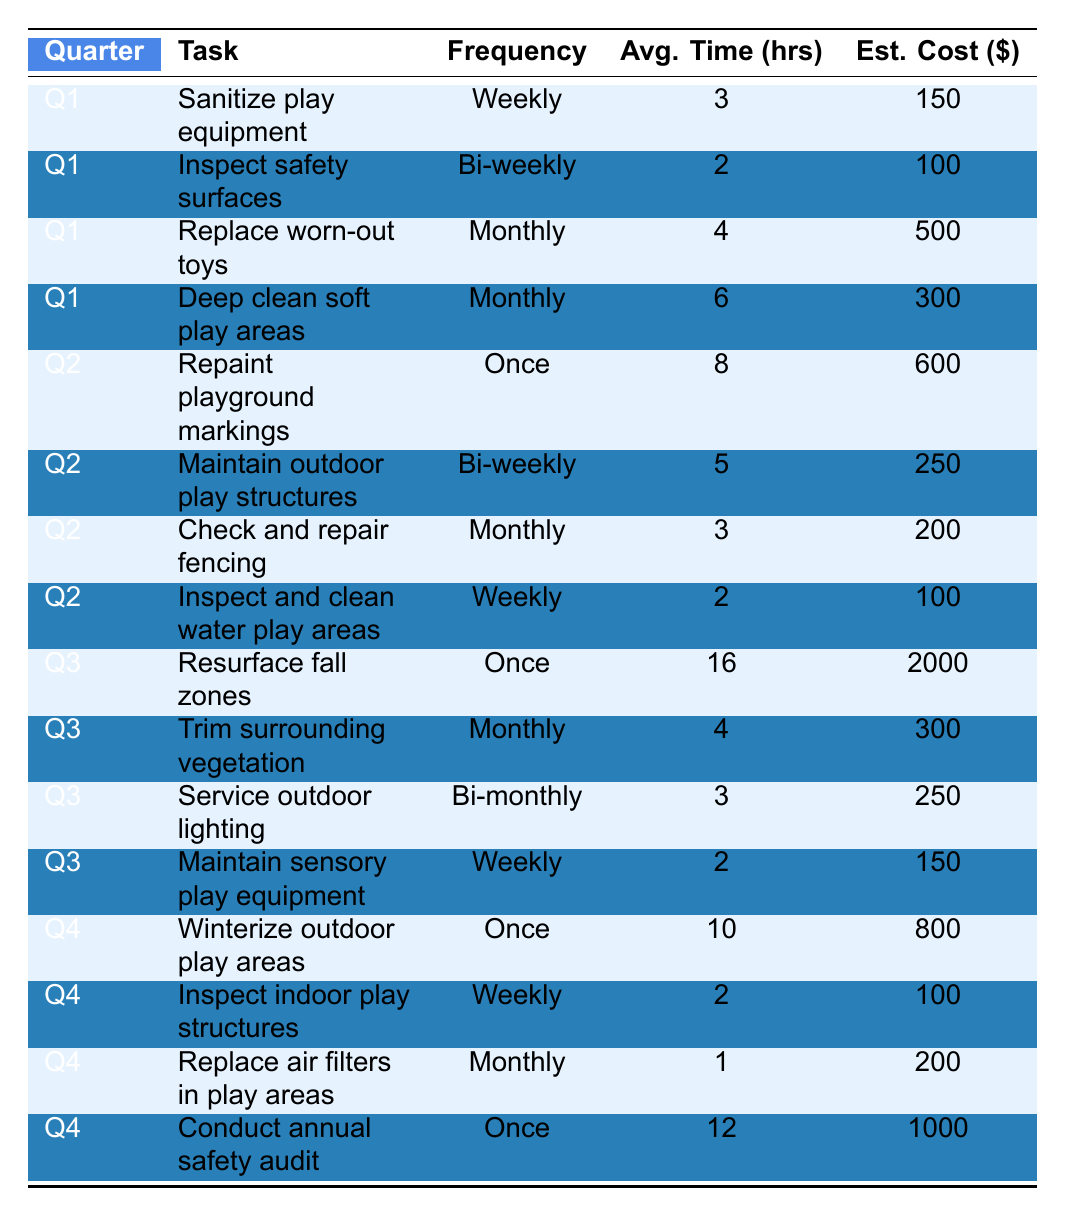What maintenance task has the highest estimated cost in Q3? In Q3, there are four tasks listed. The task "Resurface fall zones" has an estimated cost of $2000, which is higher than the other three tasks: "Trim surrounding vegetation" ($300), "Service outdoor lighting" ($250), and "Maintain sensory play equipment" ($150).
Answer: Resurface fall zones How often is the indoor play structure inspected? The table shows that the indoor play structures are inspected weekly in Q4.
Answer: Weekly What is the average time spent on tasks in Q2? The tasks in Q2 are: "Repaint playground markings" (8 hours), "Maintain outdoor play structures" (5 hours), "Check and repair fencing" (3 hours), and "Inspect and clean water play areas" (2 hours). Adding these gives 8 + 5 + 3 + 2 = 18 hours. Dividing by 4 (the number of tasks) gives an average of 18/4 = 4.5 hours.
Answer: 4.5 hours Is there a maintenance task that occurs monthly in Q4? The table lists three tasks for Q4, and one of them is "Replace air filters in play areas," which occurs monthly.
Answer: Yes What is the total estimated cost for all quarterly tasks? To find the total estimated cost, we sum each quarter's tasks: Q1 ($150 + $100 + $500 + $300), Q2 ($600 + $250 + $200 + $100), Q3 ($2000 + $300 + $250 + $150), and Q4 ($800 + $100 + $200 + $1000). Calculating these gives: Q1 = $1050, Q2 = $1150, Q3 = $2700, Q4 = $2100. Adding them together: $1050 + $1150 + $2700 + $2100 = $7100.
Answer: $7100 Which quarter has the highest total average time spent on maintenance tasks? First, we calculate total average time for each quarter: Q1 (3 + 2 + 4 + 6 = 15 hours), Q2 (8 + 5 + 3 + 2 = 18 hours), Q3 (16 + 4 + 3 + 2 = 25 hours), and Q4 (10 + 2 + 1 + 12 = 25 hours). Both Q3 and Q4 have the highest total at 25 hours.
Answer: Q3 and Q4 How does the frequency of "Replace worn-out toys" compare to "Check and repair fencing"? "Replace worn-out toys" occurs monthly, while "Check and repair fencing" also occurs monthly. Thus, both tasks have the same frequency.
Answer: Same frequency What percentage of maintenance tasks for Q1 are done weekly? For Q1, there are four tasks. Two tasks occur weekly: "Sanitize play equipment" and "Inspect safety surfaces." To find the percentage, we calculate (2/4) * 100 = 50%.
Answer: 50% Is there any task in Q2 that has a higher average time than "Maintain outdoor play structures"? "Maintain outdoor play structures" takes 5 hours. The tasks in Q2 are: "Repaint playground markings" (8 hours, higher), "Check and repair fencing" (3 hours, lower), and "Inspect and clean water play areas" (2 hours, lower). Therefore, there is one task that is higher.
Answer: Yes 